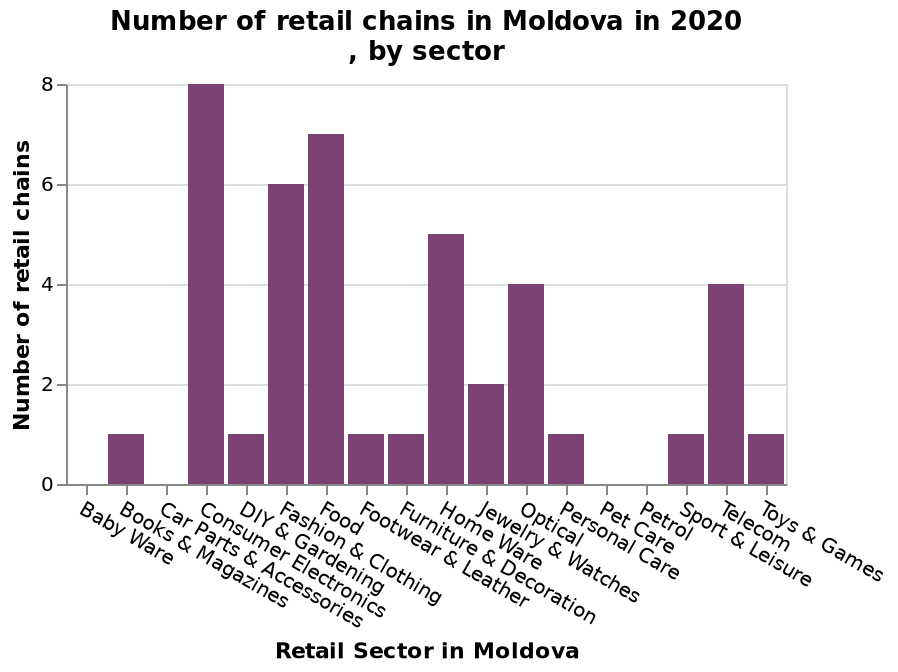<image>
please describe the details of the chart Number of retail chains in Moldova in 2020 , by sector is a bar plot. The y-axis plots Number of retail chains while the x-axis shows Retail Sector in Moldova. How would you classify retail chains?  Retail chains can be classified into specific retail sectors such as electronics, fashion, food, homeware, optical, and telecom. 